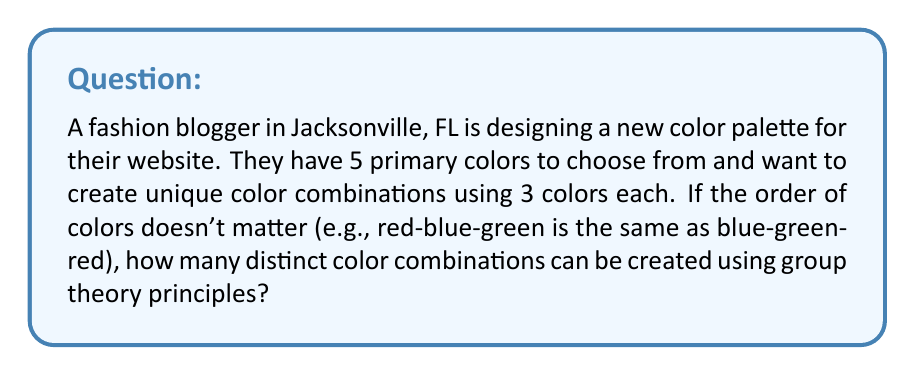Can you answer this question? To solve this problem, we can use group theory principles, specifically the concept of combinations and orbits under a group action.

1. First, let's consider the total number of ways to choose 3 colors from 5 without restrictions:
   $${5 \choose 3} = \frac{5!}{3!(5-3)!} = \frac{5 \cdot 4 \cdot 3}{3 \cdot 2 \cdot 1} = 10$$

2. However, since the order doesn't matter, we need to consider the symmetry group acting on these combinations. In this case, it's the symmetric group $S_3$, which has 6 elements (3! = 6).

3. Each orbit under this group action represents a unique color combination, regardless of order. To find the number of orbits, we can use Burnside's lemma:

   $$|X/G| = \frac{1}{|G|} \sum_{g \in G} |X^g|$$

   Where:
   - $|X/G|$ is the number of orbits
   - $|G|$ is the order of the group (in this case, 6)
   - $|X^g|$ is the number of elements fixed by each group element $g$

4. Let's count the fixed points for each element of $S_3$:
   - Identity (e): fixes all 10 combinations
   - 3 transpositions: each fixes 4 combinations
   - 2 3-cycles: each fixes 1 combination

5. Applying Burnside's lemma:

   $$|X/G| = \frac{1}{6} (10 + 4 + 4 + 4 + 1 + 1) = \frac{24}{6} = 4$$

Therefore, there are 4 distinct color combinations that can be created.
Answer: 4 distinct color combinations 